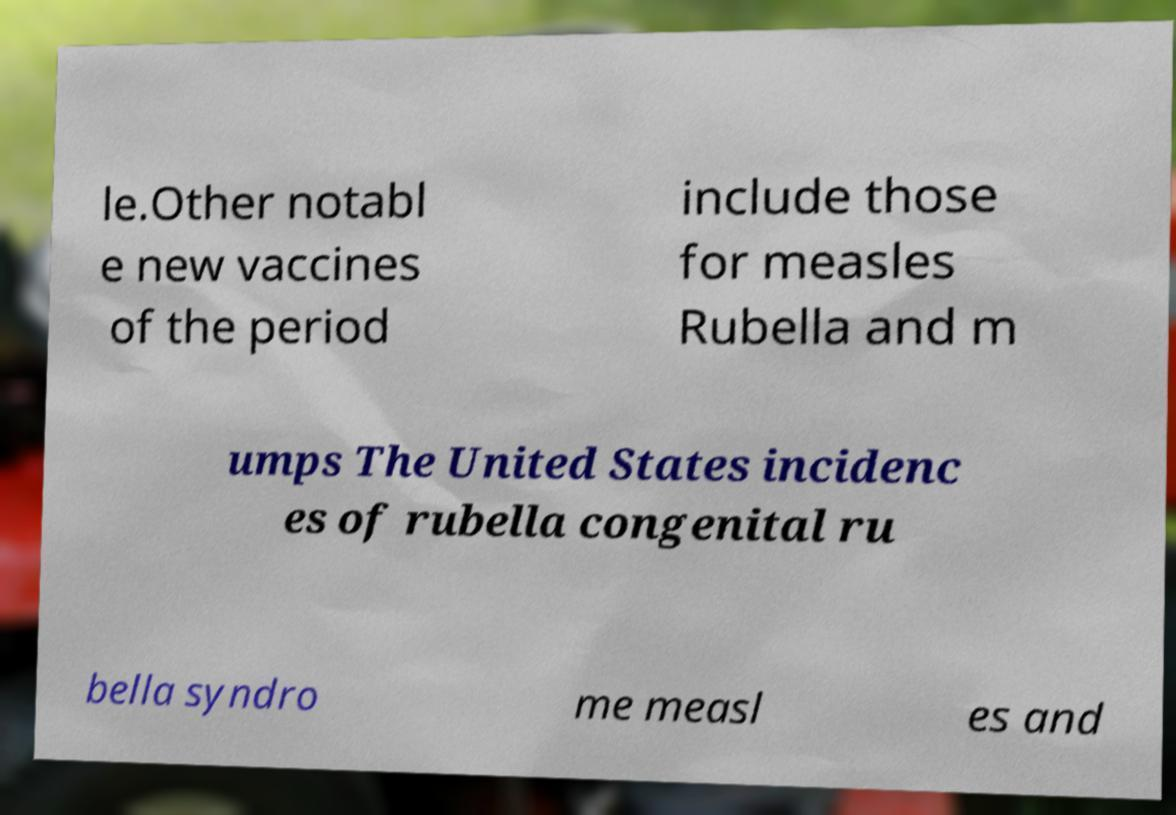For documentation purposes, I need the text within this image transcribed. Could you provide that? le.Other notabl e new vaccines of the period include those for measles Rubella and m umps The United States incidenc es of rubella congenital ru bella syndro me measl es and 